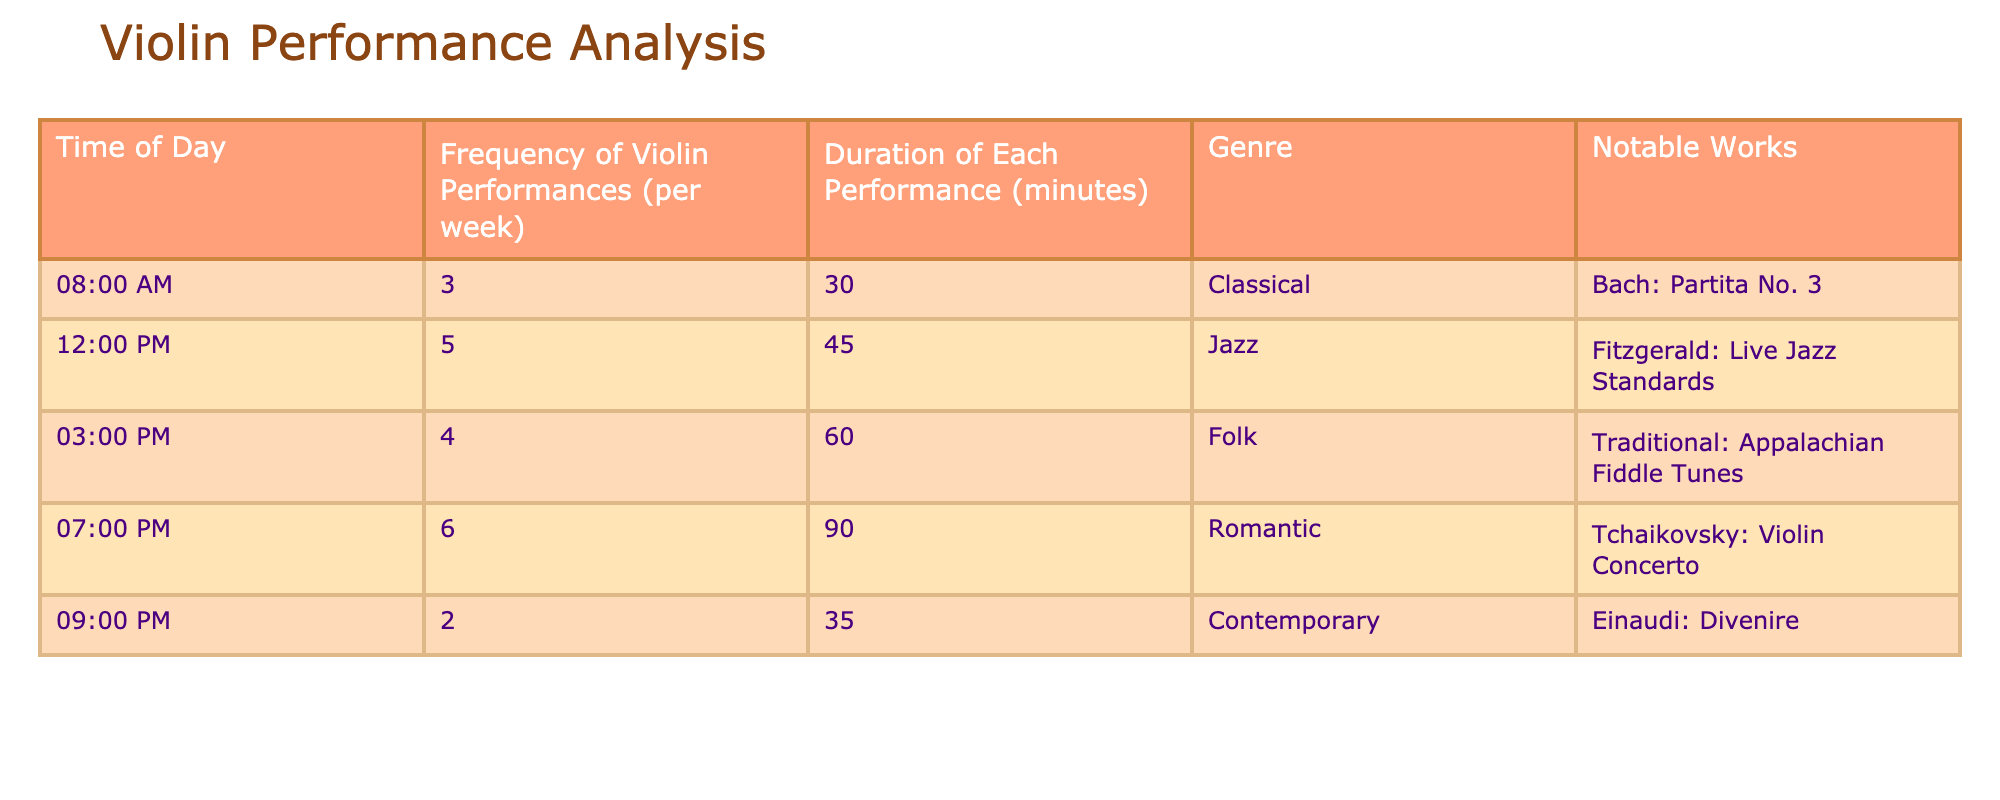What time of day has the highest frequency of violin performances? The table shows the frequency of violin performances at different times of the day. The highest frequency is listed at 07:00 PM, with 6 performances per week.
Answer: 07:00 PM How many performances take place during the lunch hour (12:00 PM)? The table indicates that there are 5 performances at 12:00 PM per week.
Answer: 5 What is the total duration of violin performances at 03:00 PM? At 03:00 PM, there are 4 performances each lasting 60 minutes. To find the total duration, multiply 4 by 60 which equals 240 minutes.
Answer: 240 minutes Which genre has the longest average duration per performance? To determine the genre with the longest average duration, we compare the duration of each genre: Classical (30 minutes), Jazz (45 minutes), Folk (60 minutes), Romantic (90 minutes), and Contemporary (35 minutes). The longest is Romantic with 90 minutes.
Answer: Romantic Is there a performance at 09:00 PM? The table lists a performance at 09:00 PM, confirming that there is indeed a performance at that time.
Answer: Yes What is the average frequency of performances across all time slots? To find the average frequency, we total the performances (3 + 5 + 4 + 6 + 2 = 20) and divide by the number of time slots (5). The average is 20 divided by 5, which equals 4.
Answer: 4 What is the difference in performance duration between the genre with the shortest and longest performances? The shortest duration is Classical at 30 minutes, and the longest is Romantic at 90 minutes. The difference is 90 - 30 = 60 minutes.
Answer: 60 minutes How many more performances are scheduled in the afternoon (12:00 PM to 04:00 PM) than in the evening (07:00 PM to 09:00 PM)? In the afternoon, the performances are: 5 (12:00 PM) + 4 (03:00 PM) = 9. In the evening, there are 6 (07:00 PM) + 2 (09:00 PM) = 8. The difference is 9 - 8 = 1.
Answer: 1 What is the total number of performances for the Folk genre? The Folk genre has 4 performances as per the table.
Answer: 4 